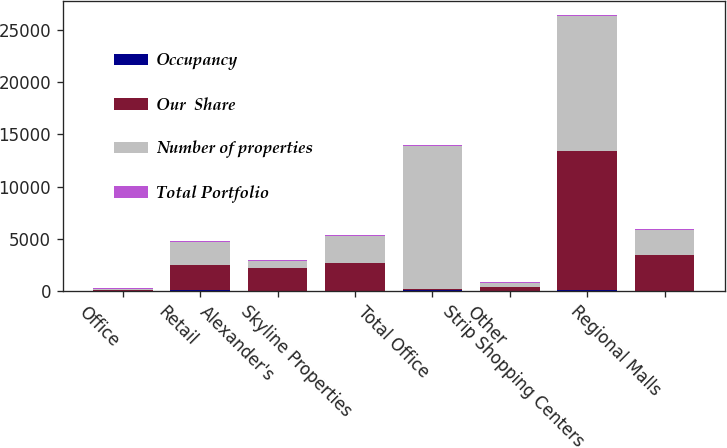<chart> <loc_0><loc_0><loc_500><loc_500><stacked_bar_chart><ecel><fcel>Office<fcel>Retail<fcel>Alexander's<fcel>Skyline Properties<fcel>Total Office<fcel>Other<fcel>Strip Shopping Centers<fcel>Regional Malls<nl><fcel>Occupancy<fcel>31<fcel>56<fcel>6<fcel>8<fcel>59<fcel>6<fcel>86<fcel>4<nl><fcel>Our  Share<fcel>99.7<fcel>2450<fcel>2178<fcel>2648<fcel>99.7<fcel>384<fcel>13346<fcel>3451<nl><fcel>Number of properties<fcel>99.7<fcel>2179<fcel>706<fcel>2648<fcel>13731<fcel>384<fcel>12920<fcel>2353<nl><fcel>Total Portfolio<fcel>96.9<fcel>96.4<fcel>99.7<fcel>53.5<fcel>80.9<fcel>100<fcel>96.1<fcel>95.1<nl></chart> 